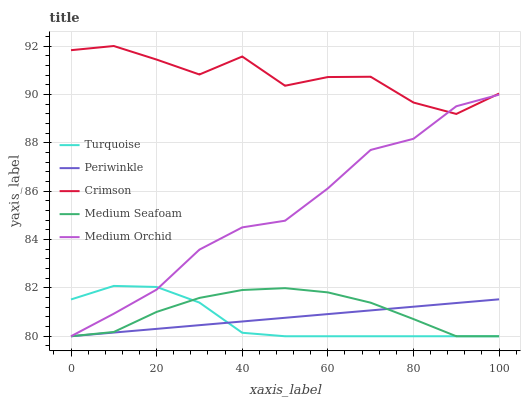Does Medium Orchid have the minimum area under the curve?
Answer yes or no. No. Does Medium Orchid have the maximum area under the curve?
Answer yes or no. No. Is Turquoise the smoothest?
Answer yes or no. No. Is Turquoise the roughest?
Answer yes or no. No. Does Turquoise have the highest value?
Answer yes or no. No. Is Turquoise less than Crimson?
Answer yes or no. Yes. Is Crimson greater than Periwinkle?
Answer yes or no. Yes. Does Turquoise intersect Crimson?
Answer yes or no. No. 